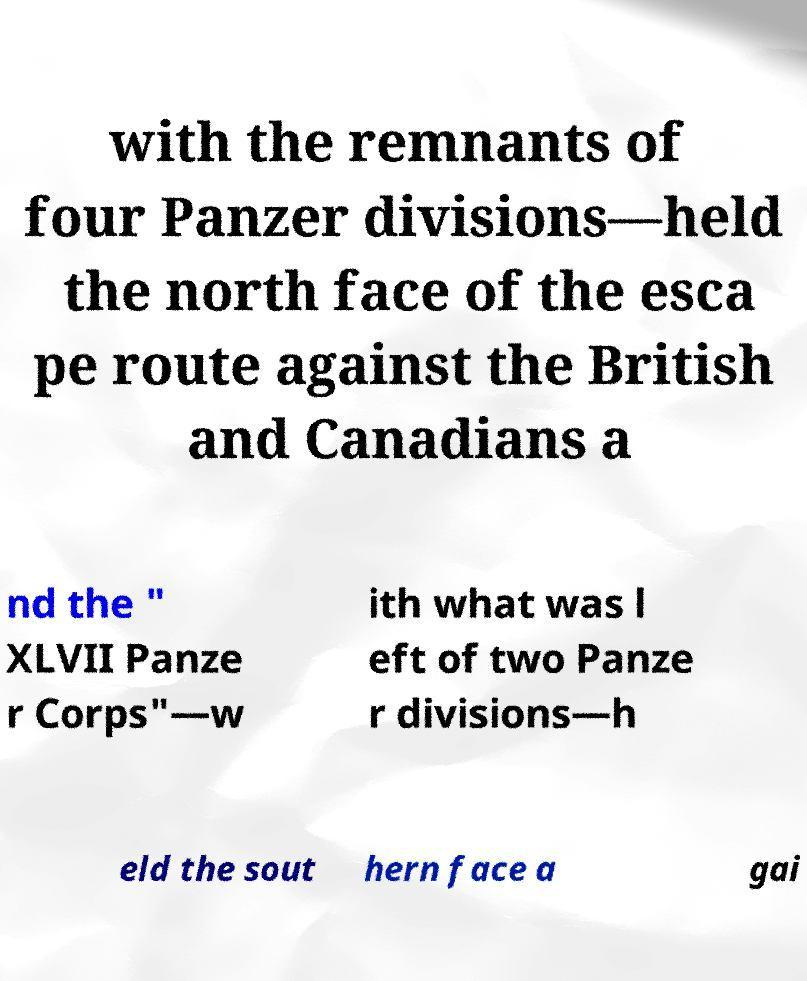For documentation purposes, I need the text within this image transcribed. Could you provide that? with the remnants of four Panzer divisions—held the north face of the esca pe route against the British and Canadians a nd the " XLVII Panze r Corps"—w ith what was l eft of two Panze r divisions—h eld the sout hern face a gai 